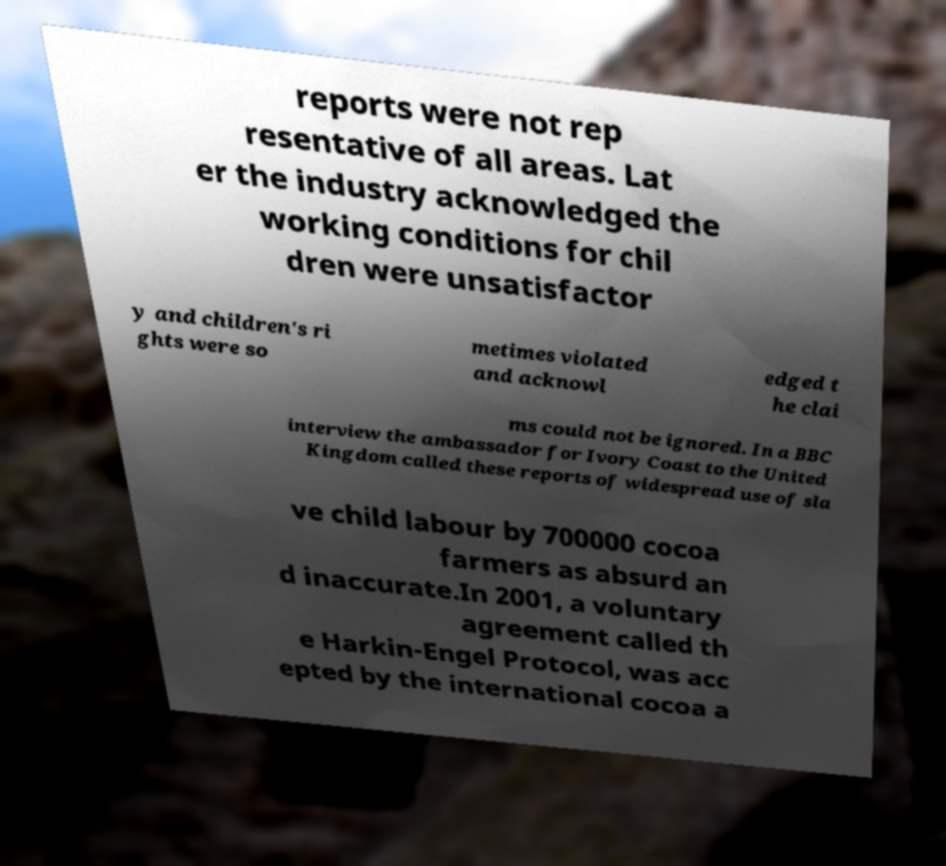Could you extract and type out the text from this image? reports were not rep resentative of all areas. Lat er the industry acknowledged the working conditions for chil dren were unsatisfactor y and children's ri ghts were so metimes violated and acknowl edged t he clai ms could not be ignored. In a BBC interview the ambassador for Ivory Coast to the United Kingdom called these reports of widespread use of sla ve child labour by 700000 cocoa farmers as absurd an d inaccurate.In 2001, a voluntary agreement called th e Harkin-Engel Protocol, was acc epted by the international cocoa a 